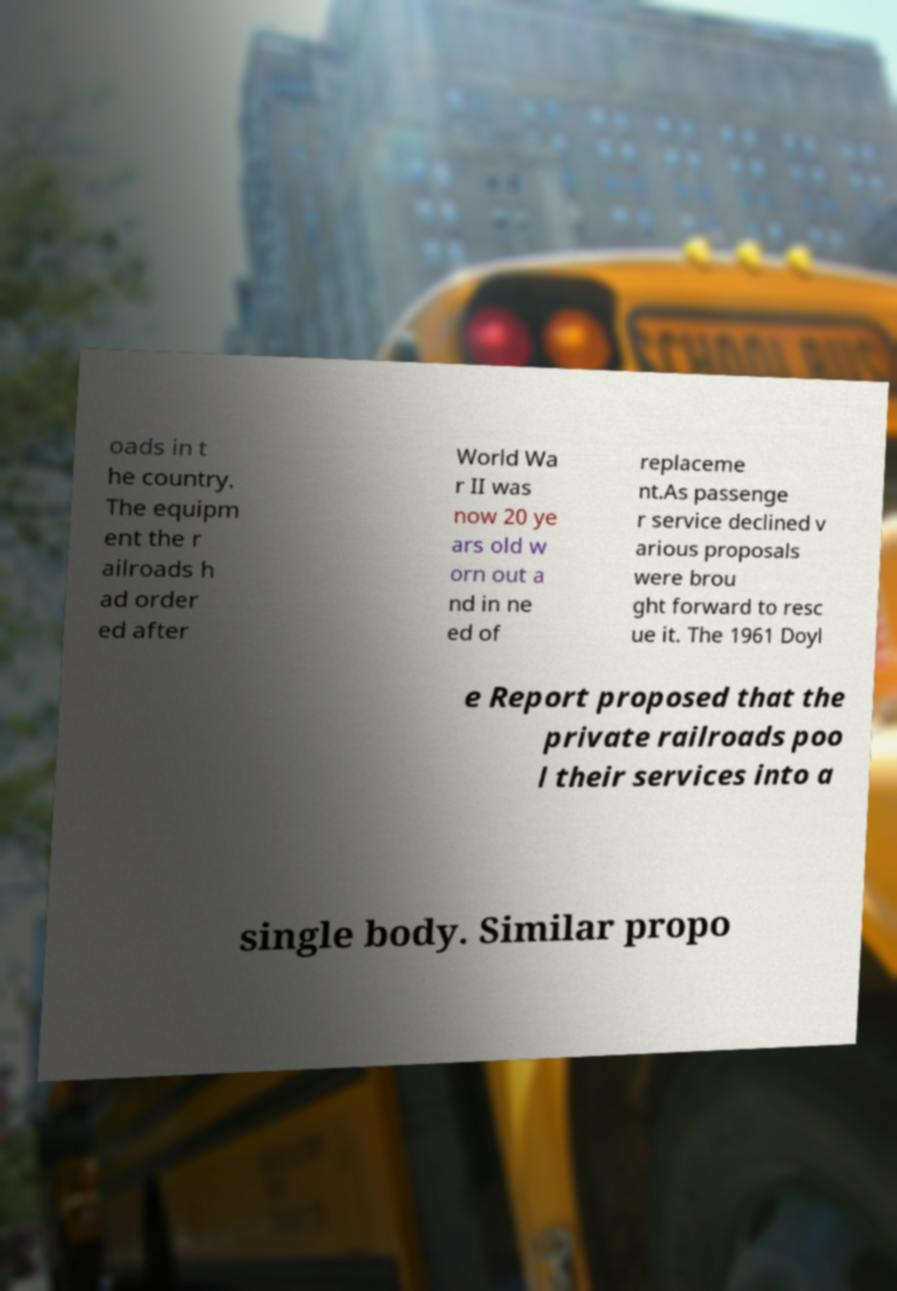Can you read and provide the text displayed in the image?This photo seems to have some interesting text. Can you extract and type it out for me? oads in t he country. The equipm ent the r ailroads h ad order ed after World Wa r II was now 20 ye ars old w orn out a nd in ne ed of replaceme nt.As passenge r service declined v arious proposals were brou ght forward to resc ue it. The 1961 Doyl e Report proposed that the private railroads poo l their services into a single body. Similar propo 